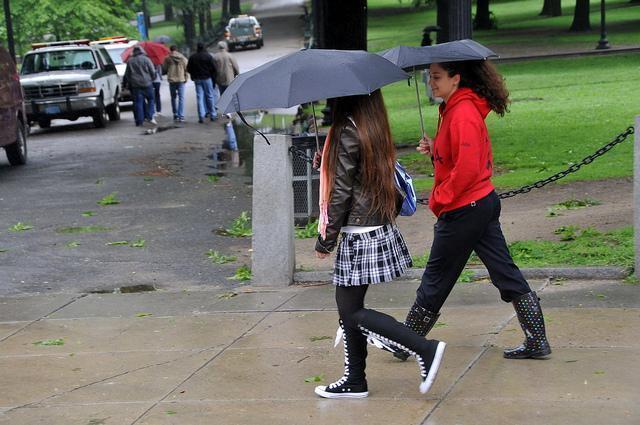How many people are in this image?
Give a very brief answer. 7. How many umbrellas are in the photo?
Give a very brief answer. 2. How many people are in the picture?
Give a very brief answer. 2. How many giraffes are looking at the camera?
Give a very brief answer. 0. 